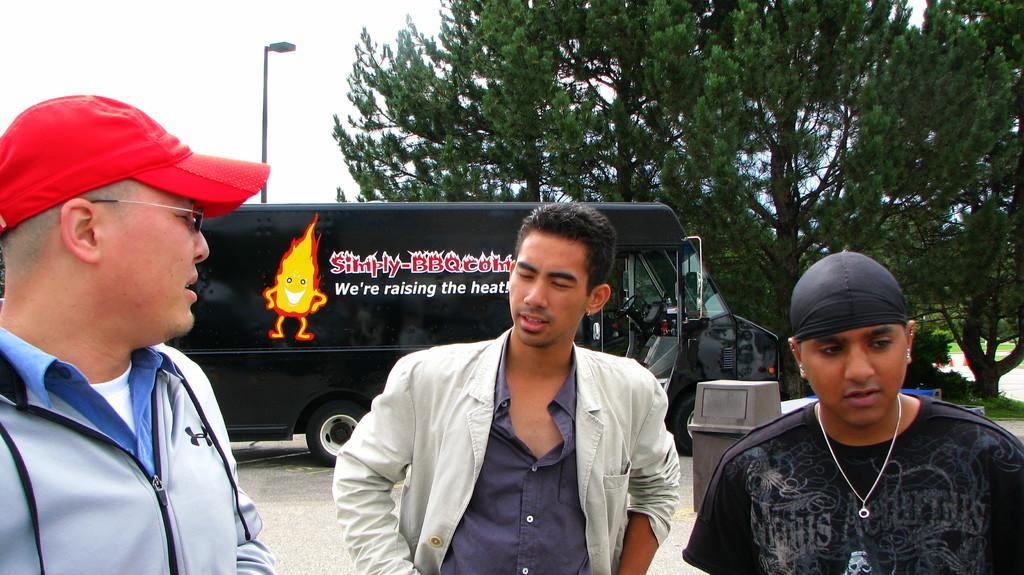Can you describe this image briefly? In this image I can see three people standing. I can see a bus, trees, a trash can and a light pole behind them. 